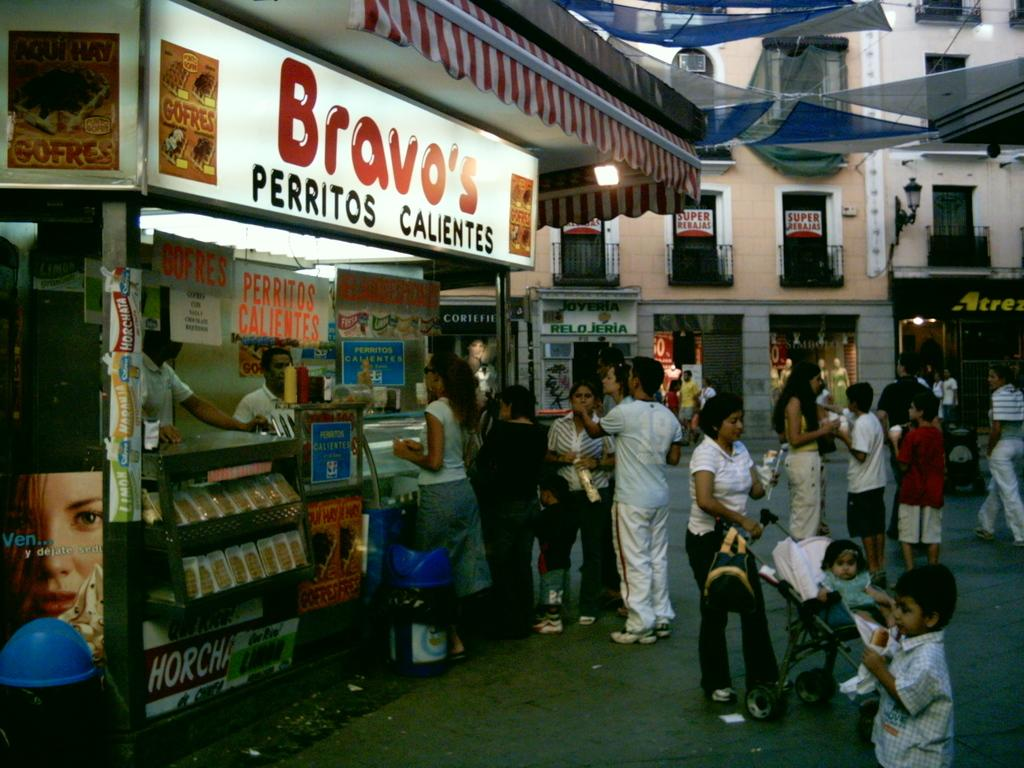What type of establishment is depicted in the image? There is a food store in the image. Can you describe the scene in front of the store? There are many people in front of the store. What can be seen in the background of the image? There is a building in the background of the image. Are there any other businesses or establishments visible in the image? Yes, there are other stores under the building in the background. What type of ornament is hanging from the edge of the building in the image? There is no ornament hanging from the edge of the building in the image. What scientific discoveries are being made inside the food store in the image? There is no indication of scientific research or discoveries being made inside the food store in the image. 